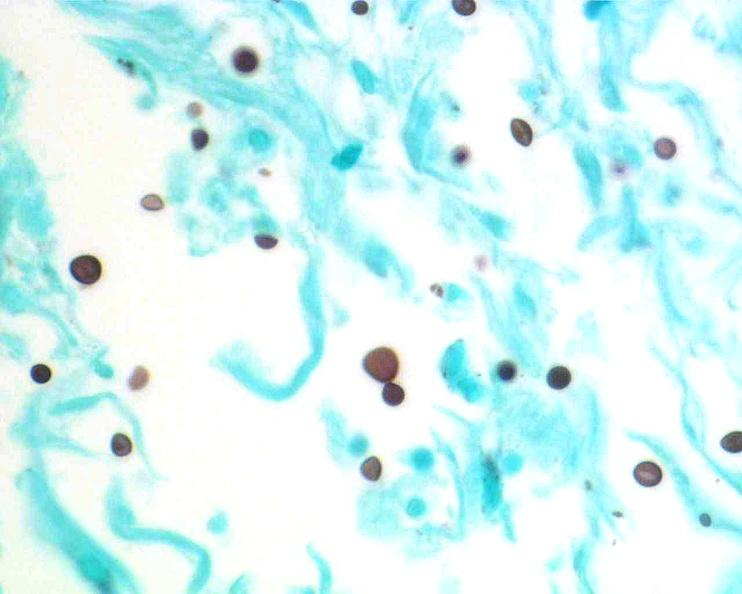s foot present?
Answer the question using a single word or phrase. No 